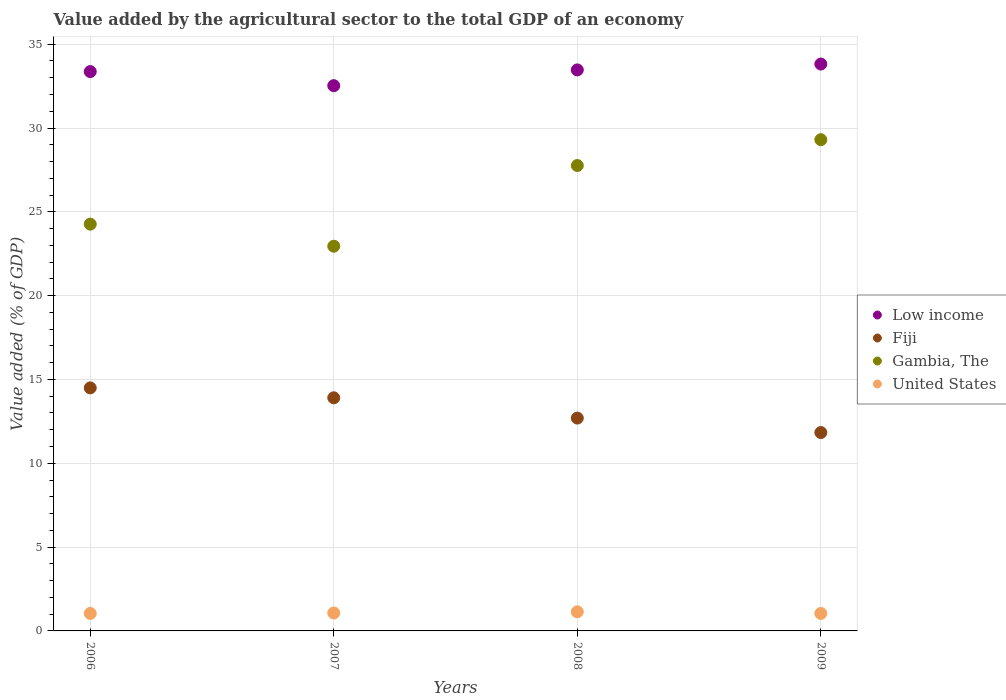How many different coloured dotlines are there?
Make the answer very short. 4. What is the value added by the agricultural sector to the total GDP in Gambia, The in 2007?
Your answer should be compact. 22.95. Across all years, what is the maximum value added by the agricultural sector to the total GDP in Fiji?
Your response must be concise. 14.5. Across all years, what is the minimum value added by the agricultural sector to the total GDP in Gambia, The?
Give a very brief answer. 22.95. In which year was the value added by the agricultural sector to the total GDP in United States minimum?
Ensure brevity in your answer.  2009. What is the total value added by the agricultural sector to the total GDP in Fiji in the graph?
Give a very brief answer. 52.94. What is the difference between the value added by the agricultural sector to the total GDP in Gambia, The in 2007 and that in 2008?
Your response must be concise. -4.81. What is the difference between the value added by the agricultural sector to the total GDP in Fiji in 2007 and the value added by the agricultural sector to the total GDP in United States in 2009?
Make the answer very short. 12.86. What is the average value added by the agricultural sector to the total GDP in Fiji per year?
Offer a terse response. 13.23. In the year 2009, what is the difference between the value added by the agricultural sector to the total GDP in Gambia, The and value added by the agricultural sector to the total GDP in United States?
Give a very brief answer. 28.26. What is the ratio of the value added by the agricultural sector to the total GDP in United States in 2007 to that in 2009?
Make the answer very short. 1.03. Is the value added by the agricultural sector to the total GDP in Low income in 2006 less than that in 2009?
Ensure brevity in your answer.  Yes. What is the difference between the highest and the second highest value added by the agricultural sector to the total GDP in Low income?
Offer a very short reply. 0.35. What is the difference between the highest and the lowest value added by the agricultural sector to the total GDP in Fiji?
Give a very brief answer. 2.66. Is it the case that in every year, the sum of the value added by the agricultural sector to the total GDP in Gambia, The and value added by the agricultural sector to the total GDP in Low income  is greater than the sum of value added by the agricultural sector to the total GDP in United States and value added by the agricultural sector to the total GDP in Fiji?
Provide a short and direct response. Yes. Does the value added by the agricultural sector to the total GDP in United States monotonically increase over the years?
Provide a short and direct response. No. Is the value added by the agricultural sector to the total GDP in Gambia, The strictly greater than the value added by the agricultural sector to the total GDP in Fiji over the years?
Offer a terse response. Yes. Is the value added by the agricultural sector to the total GDP in Gambia, The strictly less than the value added by the agricultural sector to the total GDP in Low income over the years?
Your response must be concise. Yes. How many years are there in the graph?
Ensure brevity in your answer.  4. Are the values on the major ticks of Y-axis written in scientific E-notation?
Your response must be concise. No. Does the graph contain any zero values?
Provide a succinct answer. No. How many legend labels are there?
Offer a very short reply. 4. What is the title of the graph?
Your response must be concise. Value added by the agricultural sector to the total GDP of an economy. What is the label or title of the Y-axis?
Ensure brevity in your answer.  Value added (% of GDP). What is the Value added (% of GDP) of Low income in 2006?
Offer a terse response. 33.37. What is the Value added (% of GDP) in Fiji in 2006?
Your answer should be very brief. 14.5. What is the Value added (% of GDP) of Gambia, The in 2006?
Offer a terse response. 24.27. What is the Value added (% of GDP) of United States in 2006?
Your answer should be very brief. 1.04. What is the Value added (% of GDP) in Low income in 2007?
Your answer should be compact. 32.53. What is the Value added (% of GDP) of Fiji in 2007?
Provide a short and direct response. 13.91. What is the Value added (% of GDP) in Gambia, The in 2007?
Make the answer very short. 22.95. What is the Value added (% of GDP) of United States in 2007?
Your answer should be very brief. 1.07. What is the Value added (% of GDP) of Low income in 2008?
Your answer should be compact. 33.47. What is the Value added (% of GDP) in Fiji in 2008?
Your response must be concise. 12.7. What is the Value added (% of GDP) in Gambia, The in 2008?
Your response must be concise. 27.76. What is the Value added (% of GDP) of United States in 2008?
Keep it short and to the point. 1.14. What is the Value added (% of GDP) in Low income in 2009?
Offer a terse response. 33.82. What is the Value added (% of GDP) in Fiji in 2009?
Ensure brevity in your answer.  11.83. What is the Value added (% of GDP) of Gambia, The in 2009?
Your response must be concise. 29.3. What is the Value added (% of GDP) in United States in 2009?
Keep it short and to the point. 1.04. Across all years, what is the maximum Value added (% of GDP) of Low income?
Give a very brief answer. 33.82. Across all years, what is the maximum Value added (% of GDP) of Fiji?
Ensure brevity in your answer.  14.5. Across all years, what is the maximum Value added (% of GDP) in Gambia, The?
Make the answer very short. 29.3. Across all years, what is the maximum Value added (% of GDP) of United States?
Give a very brief answer. 1.14. Across all years, what is the minimum Value added (% of GDP) of Low income?
Provide a succinct answer. 32.53. Across all years, what is the minimum Value added (% of GDP) of Fiji?
Ensure brevity in your answer.  11.83. Across all years, what is the minimum Value added (% of GDP) of Gambia, The?
Provide a succinct answer. 22.95. Across all years, what is the minimum Value added (% of GDP) in United States?
Ensure brevity in your answer.  1.04. What is the total Value added (% of GDP) in Low income in the graph?
Make the answer very short. 133.18. What is the total Value added (% of GDP) of Fiji in the graph?
Make the answer very short. 52.94. What is the total Value added (% of GDP) of Gambia, The in the graph?
Provide a short and direct response. 104.28. What is the total Value added (% of GDP) of United States in the graph?
Your answer should be compact. 4.3. What is the difference between the Value added (% of GDP) in Low income in 2006 and that in 2007?
Give a very brief answer. 0.84. What is the difference between the Value added (% of GDP) of Fiji in 2006 and that in 2007?
Offer a terse response. 0.59. What is the difference between the Value added (% of GDP) of Gambia, The in 2006 and that in 2007?
Ensure brevity in your answer.  1.32. What is the difference between the Value added (% of GDP) in United States in 2006 and that in 2007?
Your answer should be very brief. -0.03. What is the difference between the Value added (% of GDP) of Low income in 2006 and that in 2008?
Your response must be concise. -0.1. What is the difference between the Value added (% of GDP) in Fiji in 2006 and that in 2008?
Your answer should be compact. 1.8. What is the difference between the Value added (% of GDP) of Gambia, The in 2006 and that in 2008?
Provide a short and direct response. -3.5. What is the difference between the Value added (% of GDP) in United States in 2006 and that in 2008?
Your answer should be very brief. -0.1. What is the difference between the Value added (% of GDP) in Low income in 2006 and that in 2009?
Keep it short and to the point. -0.45. What is the difference between the Value added (% of GDP) of Fiji in 2006 and that in 2009?
Provide a short and direct response. 2.66. What is the difference between the Value added (% of GDP) in Gambia, The in 2006 and that in 2009?
Provide a succinct answer. -5.04. What is the difference between the Value added (% of GDP) in United States in 2006 and that in 2009?
Your answer should be compact. 0. What is the difference between the Value added (% of GDP) in Low income in 2007 and that in 2008?
Give a very brief answer. -0.94. What is the difference between the Value added (% of GDP) in Fiji in 2007 and that in 2008?
Offer a very short reply. 1.21. What is the difference between the Value added (% of GDP) of Gambia, The in 2007 and that in 2008?
Offer a terse response. -4.81. What is the difference between the Value added (% of GDP) in United States in 2007 and that in 2008?
Provide a succinct answer. -0.07. What is the difference between the Value added (% of GDP) of Low income in 2007 and that in 2009?
Your response must be concise. -1.29. What is the difference between the Value added (% of GDP) in Fiji in 2007 and that in 2009?
Ensure brevity in your answer.  2.07. What is the difference between the Value added (% of GDP) in Gambia, The in 2007 and that in 2009?
Give a very brief answer. -6.35. What is the difference between the Value added (% of GDP) of United States in 2007 and that in 2009?
Offer a terse response. 0.03. What is the difference between the Value added (% of GDP) in Low income in 2008 and that in 2009?
Your response must be concise. -0.35. What is the difference between the Value added (% of GDP) in Fiji in 2008 and that in 2009?
Your response must be concise. 0.86. What is the difference between the Value added (% of GDP) of Gambia, The in 2008 and that in 2009?
Your answer should be very brief. -1.54. What is the difference between the Value added (% of GDP) of United States in 2008 and that in 2009?
Ensure brevity in your answer.  0.1. What is the difference between the Value added (% of GDP) in Low income in 2006 and the Value added (% of GDP) in Fiji in 2007?
Provide a succinct answer. 19.46. What is the difference between the Value added (% of GDP) of Low income in 2006 and the Value added (% of GDP) of Gambia, The in 2007?
Keep it short and to the point. 10.42. What is the difference between the Value added (% of GDP) of Low income in 2006 and the Value added (% of GDP) of United States in 2007?
Make the answer very short. 32.3. What is the difference between the Value added (% of GDP) of Fiji in 2006 and the Value added (% of GDP) of Gambia, The in 2007?
Provide a short and direct response. -8.45. What is the difference between the Value added (% of GDP) in Fiji in 2006 and the Value added (% of GDP) in United States in 2007?
Give a very brief answer. 13.43. What is the difference between the Value added (% of GDP) of Gambia, The in 2006 and the Value added (% of GDP) of United States in 2007?
Provide a short and direct response. 23.2. What is the difference between the Value added (% of GDP) of Low income in 2006 and the Value added (% of GDP) of Fiji in 2008?
Offer a terse response. 20.67. What is the difference between the Value added (% of GDP) of Low income in 2006 and the Value added (% of GDP) of Gambia, The in 2008?
Your answer should be very brief. 5.6. What is the difference between the Value added (% of GDP) of Low income in 2006 and the Value added (% of GDP) of United States in 2008?
Your answer should be compact. 32.23. What is the difference between the Value added (% of GDP) of Fiji in 2006 and the Value added (% of GDP) of Gambia, The in 2008?
Your answer should be compact. -13.27. What is the difference between the Value added (% of GDP) of Fiji in 2006 and the Value added (% of GDP) of United States in 2008?
Provide a short and direct response. 13.36. What is the difference between the Value added (% of GDP) in Gambia, The in 2006 and the Value added (% of GDP) in United States in 2008?
Give a very brief answer. 23.12. What is the difference between the Value added (% of GDP) in Low income in 2006 and the Value added (% of GDP) in Fiji in 2009?
Provide a succinct answer. 21.53. What is the difference between the Value added (% of GDP) in Low income in 2006 and the Value added (% of GDP) in Gambia, The in 2009?
Your answer should be compact. 4.06. What is the difference between the Value added (% of GDP) of Low income in 2006 and the Value added (% of GDP) of United States in 2009?
Offer a terse response. 32.33. What is the difference between the Value added (% of GDP) in Fiji in 2006 and the Value added (% of GDP) in Gambia, The in 2009?
Your response must be concise. -14.81. What is the difference between the Value added (% of GDP) in Fiji in 2006 and the Value added (% of GDP) in United States in 2009?
Provide a short and direct response. 13.46. What is the difference between the Value added (% of GDP) in Gambia, The in 2006 and the Value added (% of GDP) in United States in 2009?
Make the answer very short. 23.22. What is the difference between the Value added (% of GDP) in Low income in 2007 and the Value added (% of GDP) in Fiji in 2008?
Ensure brevity in your answer.  19.83. What is the difference between the Value added (% of GDP) in Low income in 2007 and the Value added (% of GDP) in Gambia, The in 2008?
Provide a short and direct response. 4.76. What is the difference between the Value added (% of GDP) in Low income in 2007 and the Value added (% of GDP) in United States in 2008?
Keep it short and to the point. 31.39. What is the difference between the Value added (% of GDP) of Fiji in 2007 and the Value added (% of GDP) of Gambia, The in 2008?
Your answer should be very brief. -13.86. What is the difference between the Value added (% of GDP) in Fiji in 2007 and the Value added (% of GDP) in United States in 2008?
Provide a succinct answer. 12.77. What is the difference between the Value added (% of GDP) of Gambia, The in 2007 and the Value added (% of GDP) of United States in 2008?
Give a very brief answer. 21.81. What is the difference between the Value added (% of GDP) of Low income in 2007 and the Value added (% of GDP) of Fiji in 2009?
Your response must be concise. 20.69. What is the difference between the Value added (% of GDP) of Low income in 2007 and the Value added (% of GDP) of Gambia, The in 2009?
Your answer should be compact. 3.22. What is the difference between the Value added (% of GDP) in Low income in 2007 and the Value added (% of GDP) in United States in 2009?
Ensure brevity in your answer.  31.48. What is the difference between the Value added (% of GDP) of Fiji in 2007 and the Value added (% of GDP) of Gambia, The in 2009?
Your response must be concise. -15.4. What is the difference between the Value added (% of GDP) in Fiji in 2007 and the Value added (% of GDP) in United States in 2009?
Your response must be concise. 12.86. What is the difference between the Value added (% of GDP) of Gambia, The in 2007 and the Value added (% of GDP) of United States in 2009?
Make the answer very short. 21.91. What is the difference between the Value added (% of GDP) in Low income in 2008 and the Value added (% of GDP) in Fiji in 2009?
Give a very brief answer. 21.63. What is the difference between the Value added (% of GDP) of Low income in 2008 and the Value added (% of GDP) of Gambia, The in 2009?
Offer a terse response. 4.16. What is the difference between the Value added (% of GDP) in Low income in 2008 and the Value added (% of GDP) in United States in 2009?
Keep it short and to the point. 32.42. What is the difference between the Value added (% of GDP) in Fiji in 2008 and the Value added (% of GDP) in Gambia, The in 2009?
Offer a terse response. -16.61. What is the difference between the Value added (% of GDP) in Fiji in 2008 and the Value added (% of GDP) in United States in 2009?
Give a very brief answer. 11.66. What is the difference between the Value added (% of GDP) in Gambia, The in 2008 and the Value added (% of GDP) in United States in 2009?
Offer a terse response. 26.72. What is the average Value added (% of GDP) in Low income per year?
Your answer should be very brief. 33.29. What is the average Value added (% of GDP) in Fiji per year?
Ensure brevity in your answer.  13.23. What is the average Value added (% of GDP) in Gambia, The per year?
Ensure brevity in your answer.  26.07. What is the average Value added (% of GDP) of United States per year?
Your answer should be very brief. 1.07. In the year 2006, what is the difference between the Value added (% of GDP) in Low income and Value added (% of GDP) in Fiji?
Provide a short and direct response. 18.87. In the year 2006, what is the difference between the Value added (% of GDP) in Low income and Value added (% of GDP) in Gambia, The?
Make the answer very short. 9.1. In the year 2006, what is the difference between the Value added (% of GDP) of Low income and Value added (% of GDP) of United States?
Your answer should be compact. 32.32. In the year 2006, what is the difference between the Value added (% of GDP) of Fiji and Value added (% of GDP) of Gambia, The?
Provide a short and direct response. -9.77. In the year 2006, what is the difference between the Value added (% of GDP) in Fiji and Value added (% of GDP) in United States?
Your response must be concise. 13.45. In the year 2006, what is the difference between the Value added (% of GDP) of Gambia, The and Value added (% of GDP) of United States?
Keep it short and to the point. 23.22. In the year 2007, what is the difference between the Value added (% of GDP) of Low income and Value added (% of GDP) of Fiji?
Make the answer very short. 18.62. In the year 2007, what is the difference between the Value added (% of GDP) of Low income and Value added (% of GDP) of Gambia, The?
Your answer should be very brief. 9.58. In the year 2007, what is the difference between the Value added (% of GDP) in Low income and Value added (% of GDP) in United States?
Keep it short and to the point. 31.46. In the year 2007, what is the difference between the Value added (% of GDP) of Fiji and Value added (% of GDP) of Gambia, The?
Provide a succinct answer. -9.04. In the year 2007, what is the difference between the Value added (% of GDP) in Fiji and Value added (% of GDP) in United States?
Keep it short and to the point. 12.84. In the year 2007, what is the difference between the Value added (% of GDP) of Gambia, The and Value added (% of GDP) of United States?
Offer a terse response. 21.88. In the year 2008, what is the difference between the Value added (% of GDP) in Low income and Value added (% of GDP) in Fiji?
Ensure brevity in your answer.  20.77. In the year 2008, what is the difference between the Value added (% of GDP) of Low income and Value added (% of GDP) of Gambia, The?
Provide a succinct answer. 5.7. In the year 2008, what is the difference between the Value added (% of GDP) in Low income and Value added (% of GDP) in United States?
Your response must be concise. 32.33. In the year 2008, what is the difference between the Value added (% of GDP) in Fiji and Value added (% of GDP) in Gambia, The?
Ensure brevity in your answer.  -15.07. In the year 2008, what is the difference between the Value added (% of GDP) of Fiji and Value added (% of GDP) of United States?
Offer a terse response. 11.56. In the year 2008, what is the difference between the Value added (% of GDP) in Gambia, The and Value added (% of GDP) in United States?
Give a very brief answer. 26.62. In the year 2009, what is the difference between the Value added (% of GDP) in Low income and Value added (% of GDP) in Fiji?
Give a very brief answer. 21.98. In the year 2009, what is the difference between the Value added (% of GDP) of Low income and Value added (% of GDP) of Gambia, The?
Offer a very short reply. 4.51. In the year 2009, what is the difference between the Value added (% of GDP) of Low income and Value added (% of GDP) of United States?
Give a very brief answer. 32.77. In the year 2009, what is the difference between the Value added (% of GDP) of Fiji and Value added (% of GDP) of Gambia, The?
Offer a terse response. -17.47. In the year 2009, what is the difference between the Value added (% of GDP) in Fiji and Value added (% of GDP) in United States?
Your response must be concise. 10.79. In the year 2009, what is the difference between the Value added (% of GDP) of Gambia, The and Value added (% of GDP) of United States?
Your response must be concise. 28.26. What is the ratio of the Value added (% of GDP) of Low income in 2006 to that in 2007?
Your answer should be very brief. 1.03. What is the ratio of the Value added (% of GDP) in Fiji in 2006 to that in 2007?
Your answer should be compact. 1.04. What is the ratio of the Value added (% of GDP) in Gambia, The in 2006 to that in 2007?
Offer a very short reply. 1.06. What is the ratio of the Value added (% of GDP) in United States in 2006 to that in 2007?
Keep it short and to the point. 0.97. What is the ratio of the Value added (% of GDP) of Low income in 2006 to that in 2008?
Your answer should be very brief. 1. What is the ratio of the Value added (% of GDP) of Fiji in 2006 to that in 2008?
Ensure brevity in your answer.  1.14. What is the ratio of the Value added (% of GDP) of Gambia, The in 2006 to that in 2008?
Keep it short and to the point. 0.87. What is the ratio of the Value added (% of GDP) of United States in 2006 to that in 2008?
Your answer should be compact. 0.91. What is the ratio of the Value added (% of GDP) in Low income in 2006 to that in 2009?
Your answer should be very brief. 0.99. What is the ratio of the Value added (% of GDP) of Fiji in 2006 to that in 2009?
Your response must be concise. 1.23. What is the ratio of the Value added (% of GDP) of Gambia, The in 2006 to that in 2009?
Ensure brevity in your answer.  0.83. What is the ratio of the Value added (% of GDP) in Low income in 2007 to that in 2008?
Ensure brevity in your answer.  0.97. What is the ratio of the Value added (% of GDP) of Fiji in 2007 to that in 2008?
Your answer should be very brief. 1.1. What is the ratio of the Value added (% of GDP) in Gambia, The in 2007 to that in 2008?
Offer a terse response. 0.83. What is the ratio of the Value added (% of GDP) in United States in 2007 to that in 2008?
Keep it short and to the point. 0.94. What is the ratio of the Value added (% of GDP) in Low income in 2007 to that in 2009?
Make the answer very short. 0.96. What is the ratio of the Value added (% of GDP) of Fiji in 2007 to that in 2009?
Your answer should be very brief. 1.18. What is the ratio of the Value added (% of GDP) in Gambia, The in 2007 to that in 2009?
Provide a short and direct response. 0.78. What is the ratio of the Value added (% of GDP) of United States in 2007 to that in 2009?
Give a very brief answer. 1.03. What is the ratio of the Value added (% of GDP) of Low income in 2008 to that in 2009?
Keep it short and to the point. 0.99. What is the ratio of the Value added (% of GDP) in Fiji in 2008 to that in 2009?
Your response must be concise. 1.07. What is the ratio of the Value added (% of GDP) of United States in 2008 to that in 2009?
Offer a terse response. 1.1. What is the difference between the highest and the second highest Value added (% of GDP) of Low income?
Make the answer very short. 0.35. What is the difference between the highest and the second highest Value added (% of GDP) of Fiji?
Give a very brief answer. 0.59. What is the difference between the highest and the second highest Value added (% of GDP) in Gambia, The?
Give a very brief answer. 1.54. What is the difference between the highest and the second highest Value added (% of GDP) in United States?
Provide a succinct answer. 0.07. What is the difference between the highest and the lowest Value added (% of GDP) in Low income?
Keep it short and to the point. 1.29. What is the difference between the highest and the lowest Value added (% of GDP) in Fiji?
Provide a short and direct response. 2.66. What is the difference between the highest and the lowest Value added (% of GDP) of Gambia, The?
Give a very brief answer. 6.35. What is the difference between the highest and the lowest Value added (% of GDP) in United States?
Keep it short and to the point. 0.1. 